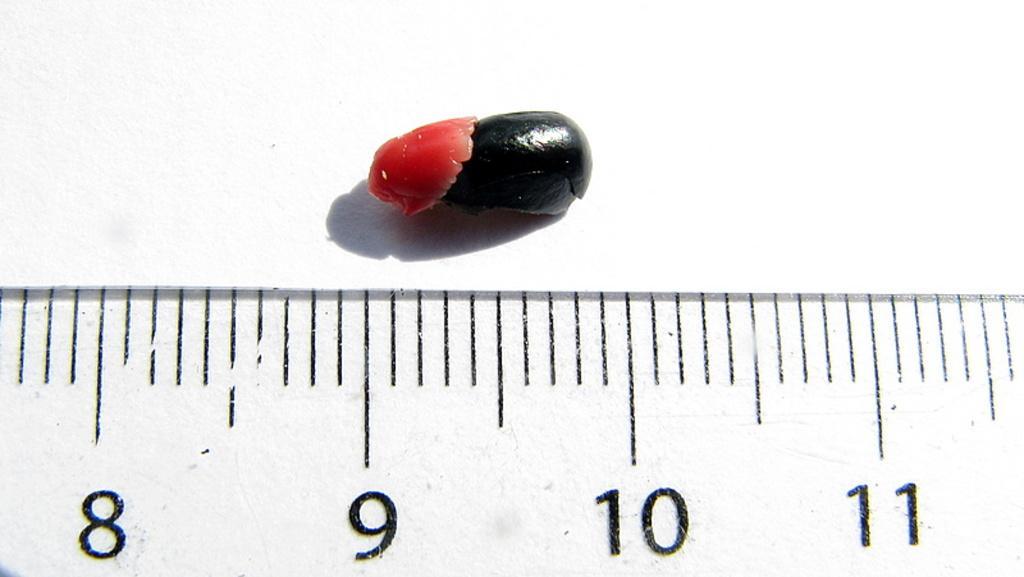What type of creature can be seen in the image? There is a bug in the image. What information is provided by the scale readings in the image? The scale readings provide information about weight or size. What color is the surface in the image? The surface in the image is white. What type of wall is the bug hiding behind in the image? There is no wall present in the image, and the bug is not hiding behind anything. 